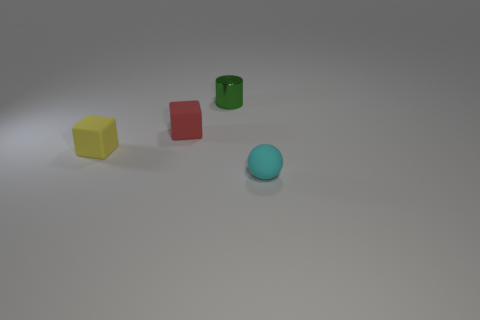Is there any other thing that has the same color as the cylinder?
Provide a succinct answer. No. Is the number of metallic blocks greater than the number of cyan spheres?
Offer a terse response. No. Does the sphere have the same material as the red object?
Your response must be concise. Yes. How many other tiny cylinders are made of the same material as the green cylinder?
Your answer should be compact. 0. Does the cyan matte ball have the same size as the cube in front of the tiny red matte cube?
Give a very brief answer. Yes. What is the color of the small rubber object that is both on the left side of the tiny green cylinder and on the right side of the small yellow rubber block?
Offer a very short reply. Red. Is there a yellow rubber cube that is behind the thing that is right of the metallic thing?
Provide a short and direct response. Yes. Are there an equal number of small rubber objects behind the small green shiny object and tiny green cylinders?
Offer a very short reply. No. What number of tiny rubber objects are to the right of the small block on the left side of the matte thing behind the yellow rubber object?
Make the answer very short. 2. Is there a block that has the same size as the metal cylinder?
Your response must be concise. Yes. 